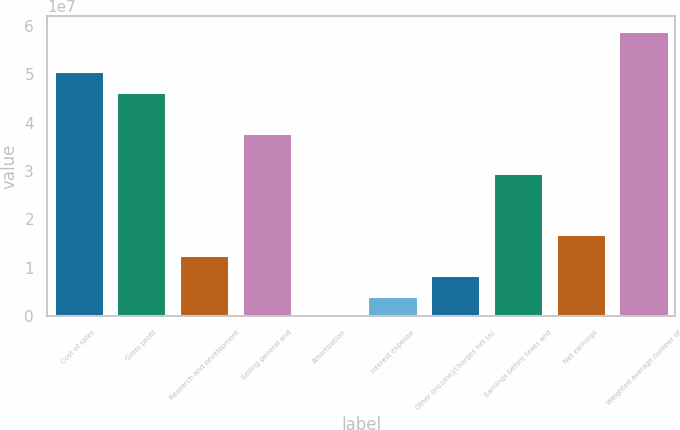Convert chart to OTSL. <chart><loc_0><loc_0><loc_500><loc_500><bar_chart><fcel>Cost of sales<fcel>Gross profit<fcel>Research and development<fcel>Selling general and<fcel>Amortization<fcel>Interest expense<fcel>Other (income)/charges net (a)<fcel>Earnings before taxes and<fcel>Net earnings<fcel>Weighted average number of<nl><fcel>5.0647e+07<fcel>4.64274e+07<fcel>1.26703e+07<fcel>3.79881e+07<fcel>11436<fcel>4.23107e+06<fcel>8.4507e+06<fcel>2.95489e+07<fcel>1.689e+07<fcel>5.90863e+07<nl></chart> 